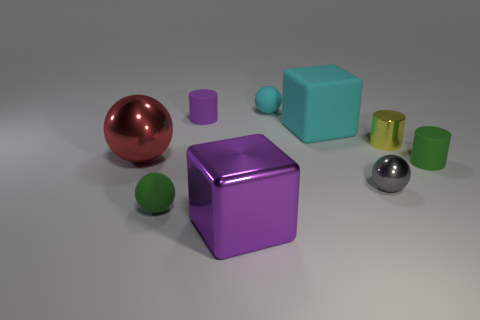Subtract all gray shiny spheres. How many spheres are left? 3 Subtract all purple cylinders. How many cylinders are left? 2 Subtract 2 cylinders. How many cylinders are left? 1 Subtract all cylinders. How many objects are left? 6 Add 1 red things. How many objects exist? 10 Subtract all small green balls. Subtract all tiny yellow metallic cylinders. How many objects are left? 7 Add 7 big shiny spheres. How many big shiny spheres are left? 8 Add 7 yellow metal cylinders. How many yellow metal cylinders exist? 8 Subtract 0 green blocks. How many objects are left? 9 Subtract all gray cubes. Subtract all gray cylinders. How many cubes are left? 2 